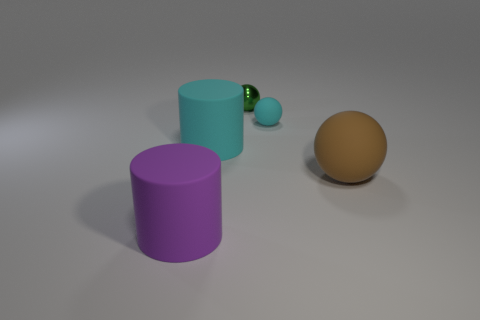Is the number of green metal objects less than the number of big objects?
Your response must be concise. Yes. The thing that is both on the right side of the small green sphere and behind the big matte ball has what shape?
Provide a short and direct response. Sphere. What number of large purple cylinders are there?
Give a very brief answer. 1. The cylinder that is in front of the ball that is in front of the large rubber thing that is behind the brown rubber sphere is made of what material?
Provide a succinct answer. Rubber. There is a cyan rubber object that is in front of the small cyan sphere; how many green objects are to the left of it?
Offer a terse response. 0. There is another tiny thing that is the same shape as the green metal thing; what color is it?
Your answer should be compact. Cyan. Is the purple cylinder made of the same material as the cyan cylinder?
Your answer should be very brief. Yes. What number of spheres are big cyan objects or small green things?
Your response must be concise. 1. There is a matte object behind the rubber cylinder on the right side of the big purple matte thing in front of the big cyan matte cylinder; what is its size?
Your answer should be compact. Small. There is another rubber thing that is the same shape as the big purple thing; what is its size?
Make the answer very short. Large. 